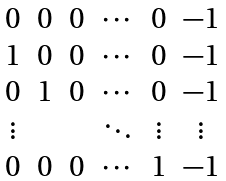<formula> <loc_0><loc_0><loc_500><loc_500>\begin{matrix} 0 & 0 & 0 & \cdots & 0 & - 1 \\ 1 & 0 & 0 & \cdots & 0 & - 1 \\ 0 & 1 & 0 & \cdots & 0 & - 1 \\ \vdots & & & \ddots & \vdots & \vdots \\ 0 & 0 & 0 & \cdots & 1 & - 1 \end{matrix}</formula> 